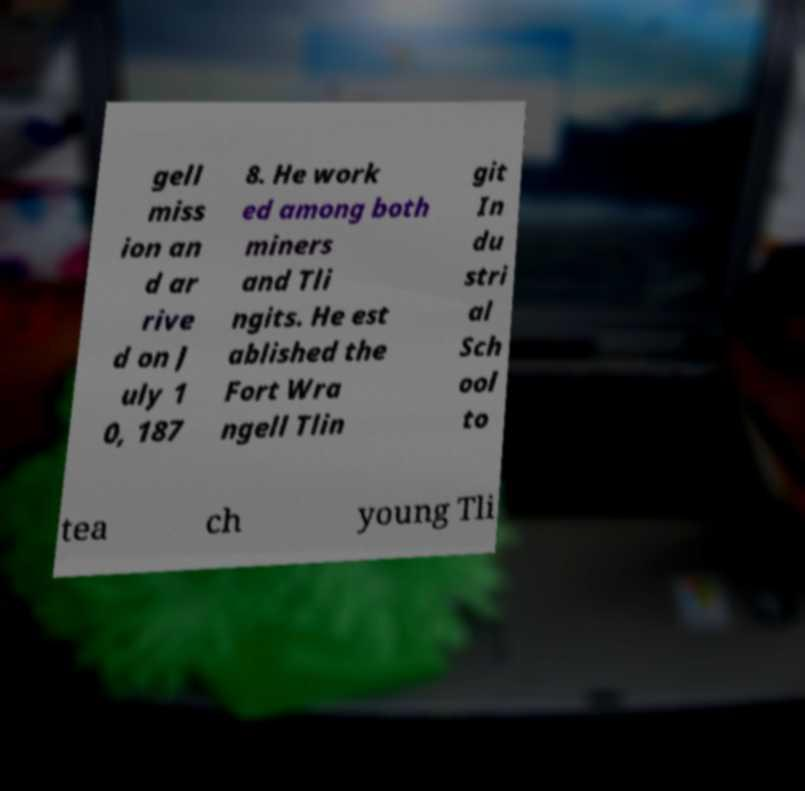Could you extract and type out the text from this image? gell miss ion an d ar rive d on J uly 1 0, 187 8. He work ed among both miners and Tli ngits. He est ablished the Fort Wra ngell Tlin git In du stri al Sch ool to tea ch young Tli 